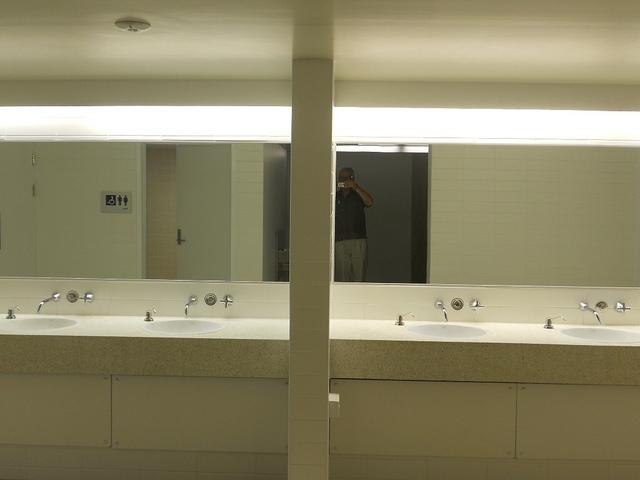What bathroom is it on the right? Please explain your reasoning. men. There is a man in this bathroom.  it is a bathroom that has multiple stalls, and is not residential. 